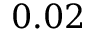Convert formula to latex. <formula><loc_0><loc_0><loc_500><loc_500>0 . 0 2</formula> 